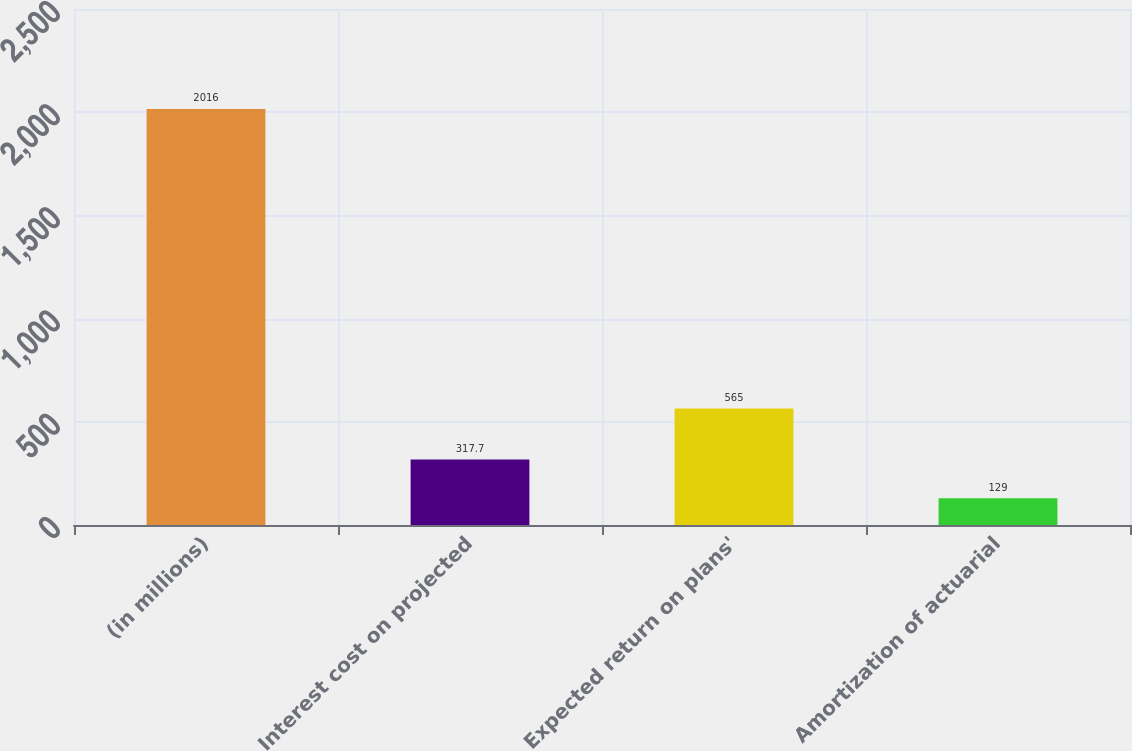Convert chart. <chart><loc_0><loc_0><loc_500><loc_500><bar_chart><fcel>(in millions)<fcel>Interest cost on projected<fcel>Expected return on plans'<fcel>Amortization of actuarial<nl><fcel>2016<fcel>317.7<fcel>565<fcel>129<nl></chart> 